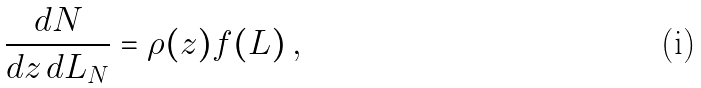<formula> <loc_0><loc_0><loc_500><loc_500>\frac { d N } { d z \, d L _ { N } } = \rho ( z ) f ( L ) \, ,</formula> 